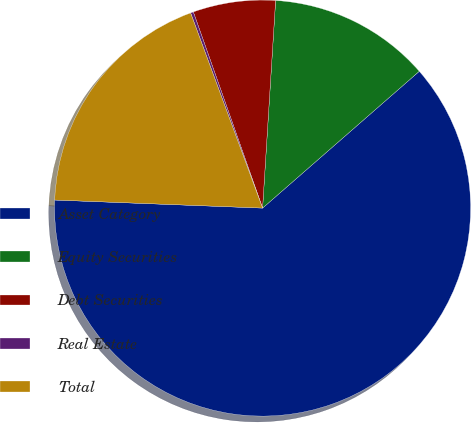Convert chart to OTSL. <chart><loc_0><loc_0><loc_500><loc_500><pie_chart><fcel>Asset Category<fcel>Equity Securities<fcel>Debt Securities<fcel>Real Estate<fcel>Total<nl><fcel>62.04%<fcel>12.58%<fcel>6.4%<fcel>0.22%<fcel>18.76%<nl></chart> 